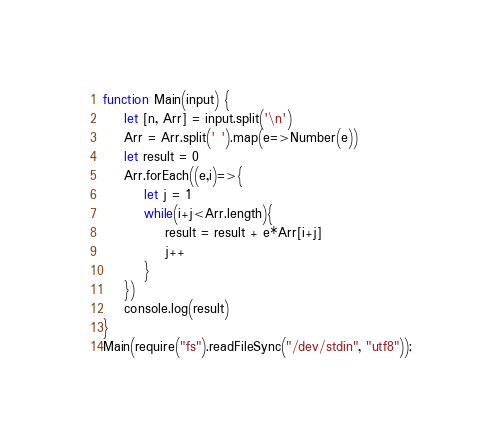<code> <loc_0><loc_0><loc_500><loc_500><_JavaScript_>function Main(input) {
	let [n, Arr] = input.split('\n')
    Arr = Arr.split(' ').map(e=>Number(e))
  	let result = 0
  	Arr.forEach((e,i)=>{	
      	let j = 1
    	while(i+j<Arr.length){
          	result = result + e*Arr[i+j]
        	j++
        }
    })
  	console.log(result)
}
Main(require("fs").readFileSync("/dev/stdin", "utf8"));</code> 